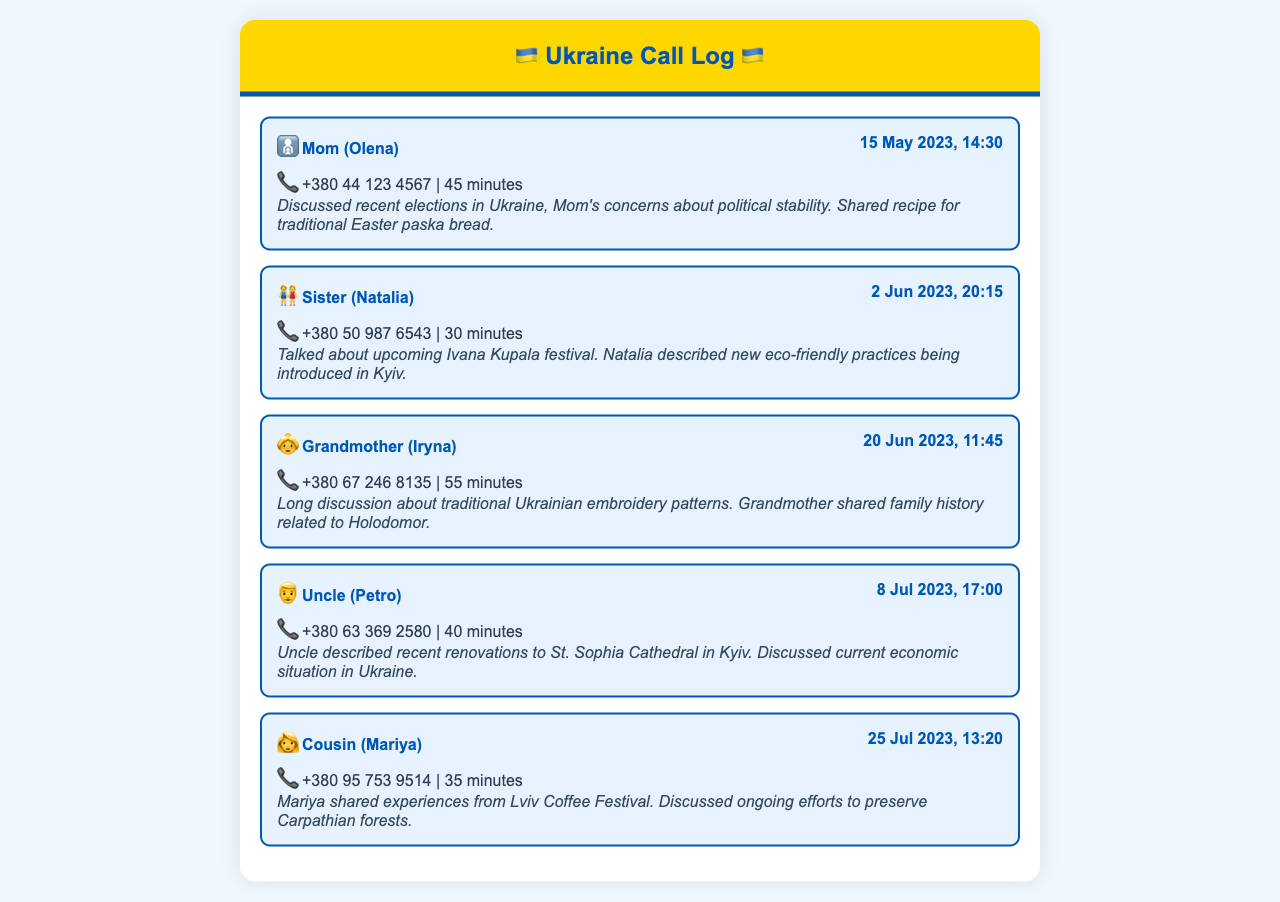What date did I call my mom? The date of the call to Mom is listed in the first call entry, which is 15 May 2023.
Answer: 15 May 2023 How long was the call with my sister? The duration of the call with Sister Natalia is specified as 30 minutes in the call entry.
Answer: 30 minutes What was discussed during the call with my grandmother? The call summary for the conversation with Grandmother Iryna mentions discussing traditional Ukrainian embroidery patterns and family history related to Holodomor.
Answer: Traditional Ukrainian embroidery patterns; Holodomor When did I talk to my uncle? The date of the call with Uncle Petro is mentioned in the document, which is 8 Jul 2023.
Answer: 8 Jul 2023 Which festival was discussed during the call with my sister? The conversation with Sister Natalia included talking about the upcoming Ivana Kupala festival.
Answer: Ivana Kupala festival What is the phone number of my cousin? The phone number for Cousin Mariya is provided in the call entry, which is +380 95 753 9514.
Answer: +380 95 753 9514 Which family member shared experiences from a festival in Lviv? The call entry indicates that Cousin Mariya shared experiences from the Lviv Coffee Festival.
Answer: Cousin Mariya What did Uncle Petro describe in his call? The call summary indicates that Uncle Petro described recent renovations to St. Sophia Cathedral in Kyiv.
Answer: Renovations to St. Sophia Cathedral How many minutes was my call with my grandmother? The duration of the call with Grandmother Iryna is 55 minutes as stated in the call log.
Answer: 55 minutes 